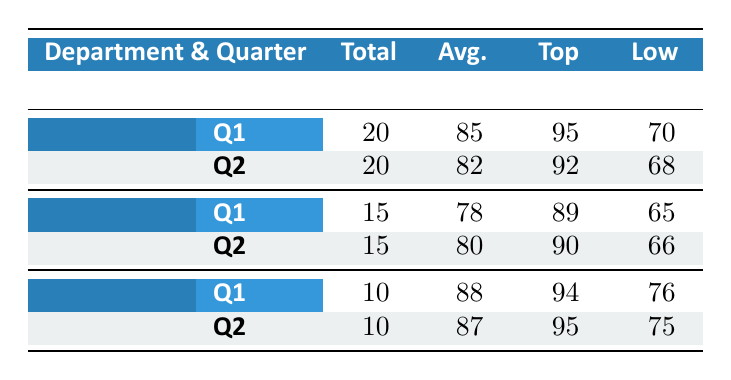What is the Average Performance Score for the Sales department in Q1? In the Sales section, under Q1, the Average Performance Score is directly listed as 85.
Answer: 85 Which department had the highest Average Performance Score in Q2? Comparing the Average Performance Scores for each department in Q2, Sales had 82, Marketing had 80, and Engineering had 87. The highest score is 87 from the Engineering department.
Answer: Engineering Who was the Lowest Performer in Marketing for Q1? In the Marketing section for Q1, the Lowest Performer is indicated as Chris Lee with a Performance Score of 65.
Answer: Chris Lee What is the difference between the Average Performance Scores of Engineering in Q1 and Q2? The Average Performance Score for Engineering in Q1 is 88 and in Q2 is 87. The difference is calculated as 88 - 87, which equals 1.
Answer: 1 Did any department have the same number of Total Employees in both quarters? Looking at the Total Employees for each department, Sales has 20 in both Q1 and Q2, Marketing has 15 in both, and Engineering has 10 in both. Therefore, yes, all departments have the same number of Total Employees in both quarters.
Answer: Yes What is the combined Average Performance Score for all departments in Q2? The Average Performance Scores in Q2 are 82 (Sales), 80 (Marketing), and 87 (Engineering). Adding these scores gives: 82 + 80 + 87 = 249. Then, dividing by the number of departments (3) results in an average Score of 249 / 3 = 83.
Answer: 83 Which quarter had a Top Performer in Sales with a Sales Achieved figure over 250,000? In Sales, during Q1, the Top Performer is John Doe with Sales Achieved of 250,000. In Q2, Alice Johnson has a Sales Achieved of 240,000. Hence, only Q1 had a Top Performer with Sales Achieved equal to or more than 250,000.
Answer: Q1 Identify the Engineering employee with the highest Performance Score in Q2 and their Projects Completed. The Top Performer in Engineering for Q2 is Sophia Garcia with a Performance Score of 95 and she completed 5 Projects.
Answer: Sophia Garcia, 5 Projects What is the average Performance Score of the lowest performers across all departments for Q1? The Lowest Performers for Q1 are Jane Smith (70 in Sales), Chris Lee (65 in Marketing), and Laura Kim (76 in Engineering). Adding these Scores gives: 70 + 65 + 76 = 211. There are three lowest performers, so the average is 211 / 3 = 70.33.
Answer: 70.33 